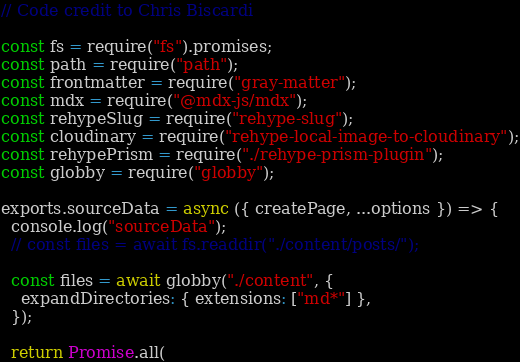<code> <loc_0><loc_0><loc_500><loc_500><_JavaScript_>// Code credit to Chris Biscardi

const fs = require("fs").promises;
const path = require("path");
const frontmatter = require("gray-matter");
const mdx = require("@mdx-js/mdx");
const rehypeSlug = require("rehype-slug");
const cloudinary = require("rehype-local-image-to-cloudinary");
const rehypePrism = require("./rehype-prism-plugin");
const globby = require("globby");

exports.sourceData = async ({ createPage, ...options }) => {
  console.log("sourceData");
  // const files = await fs.readdir("./content/posts/");

  const files = await globby("./content", {
    expandDirectories: { extensions: ["md*"] },
  });

  return Promise.all(</code> 